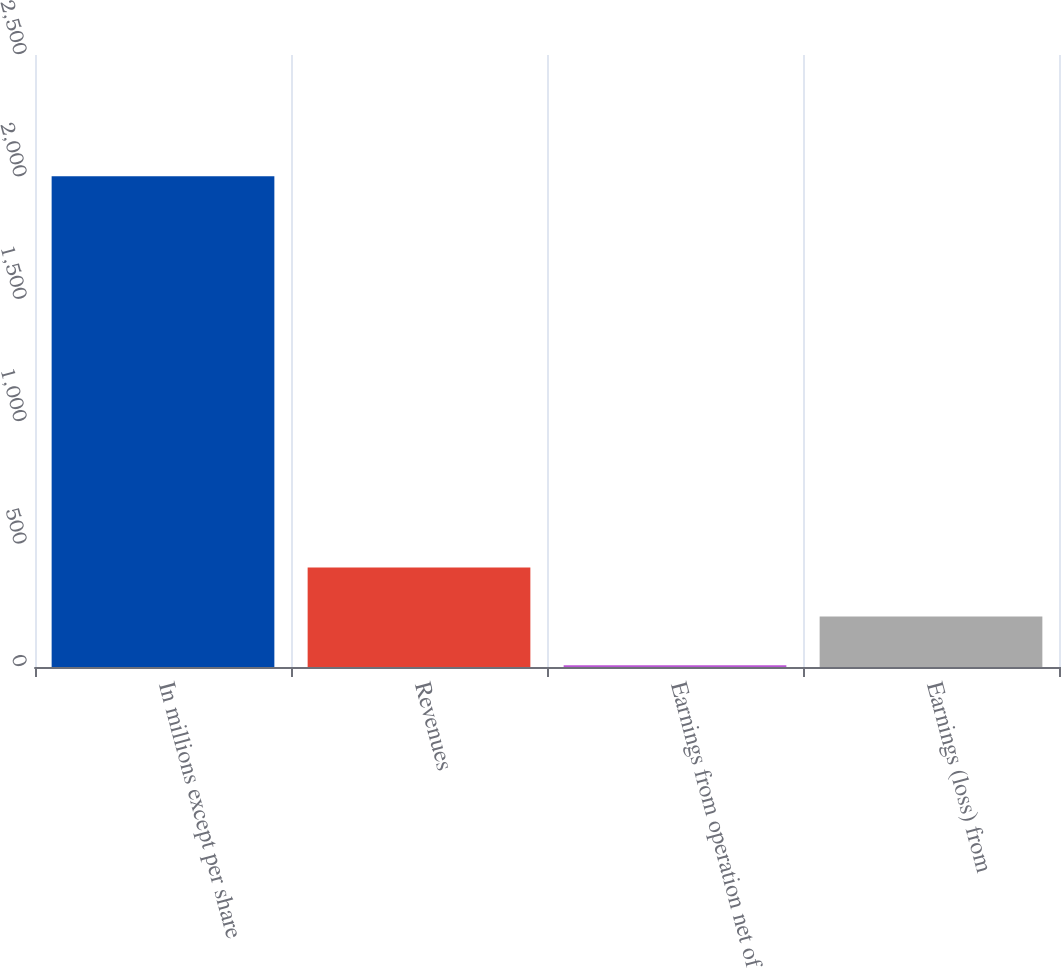Convert chart. <chart><loc_0><loc_0><loc_500><loc_500><bar_chart><fcel>In millions except per share<fcel>Revenues<fcel>Earnings from operation net of<fcel>Earnings (loss) from<nl><fcel>2005<fcel>406.6<fcel>7<fcel>206.8<nl></chart> 